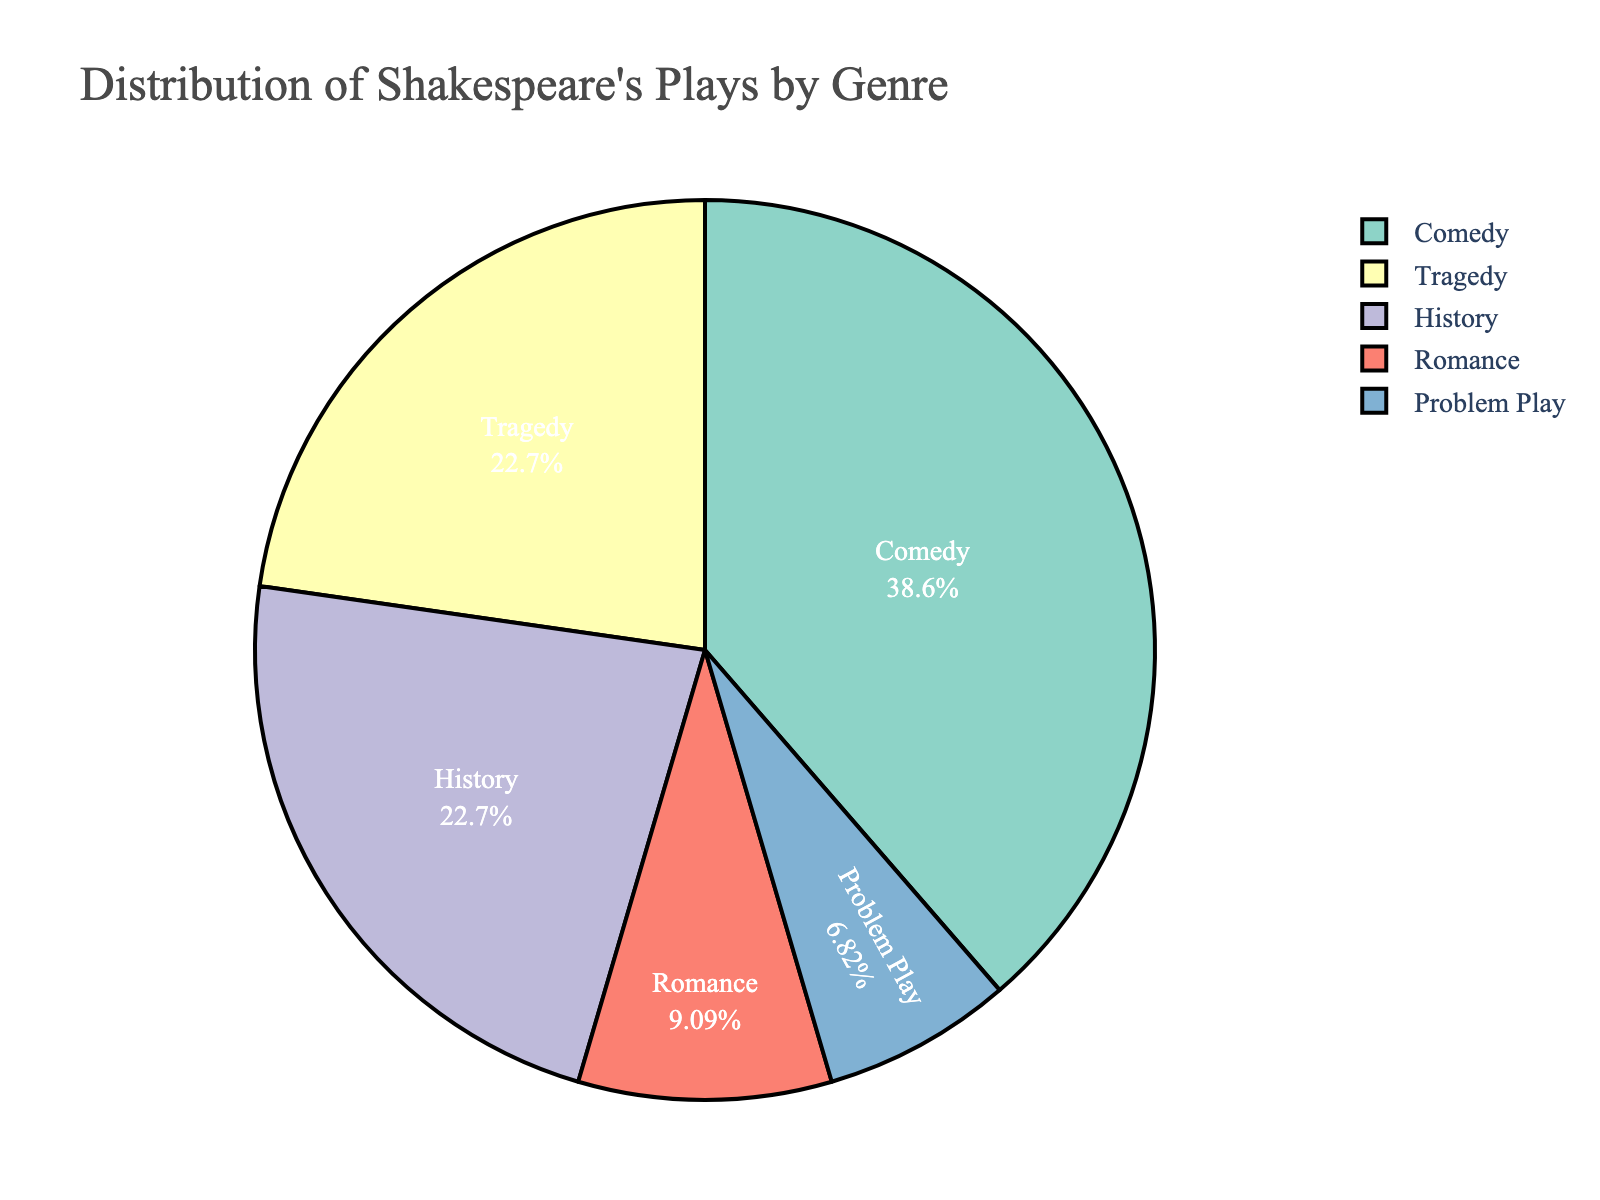what is the genre with the highest number of plays? By looking at the pie chart, we can see that the largest section corresponds to "Comedy", indicating that it has the highest number of plays.
Answer: Comedy How many more Comedies are there compared to Romances? From the chart, Comedy has 17 plays and Romance has 4 plays. The difference is 17 - 4 = 13.
Answer: 13 What's the combined percentage of Tragedy and History plays? The percentages are displayed inside the pie chart slices. Tragedy and History each have 10 plays. Knowing there are 44 plays in total, (10/44 + 10/44) * 100 = 45.45%.
Answer: 45.45% Which genre has fewer plays: Problem Play or Romance? The chart shows that Problem Play has 3 plays and Romance has 4 plays. 3 is less than 4.
Answer: Problem Play What genres comprise over 50% of Shakespeare's plays in total? From the chart, we can sum the percentages of each genre. Comedy represents around 38.64%, Tragedy 22.73%, and History 22.73%. Together, Comedy and Tragedy already sum to 61.37%, which is over 50%.
Answer: Comedy and Tragedy What fraction of the total plays does the Problem Play genre represent? The pie chart shows that Problem Play has 3 out of the 44 total plays. The fraction is thus 3/44.
Answer: 3/44 How does the number of Tragedy plays compare to the number of History plays? According to the chart, both Tragedy and History each have 10 plays. Therefore, the number is equal.
Answer: Equal What is the percentage of plays in the Romance genre? Romance has 4 plays out of the total 44 plays. Calculating the percentage, (4/44) * 100 ≈ 9.09%.
Answer: 9.09% How many plays are non-comedic (not in the comedy genre)? From the chart, there are 44 total plays and 17 are comedies. Subtracting, 44 - 17 = 27 non-comedic plays.
Answer: 27 Is there any genre that represents less than 10% of Shakespeare's plays? From the chart, the only genre representing less than 10% is Problem Play with 3 plays, which is (3/44) * 100 ≈ 6.82%.
Answer: Problem Play 